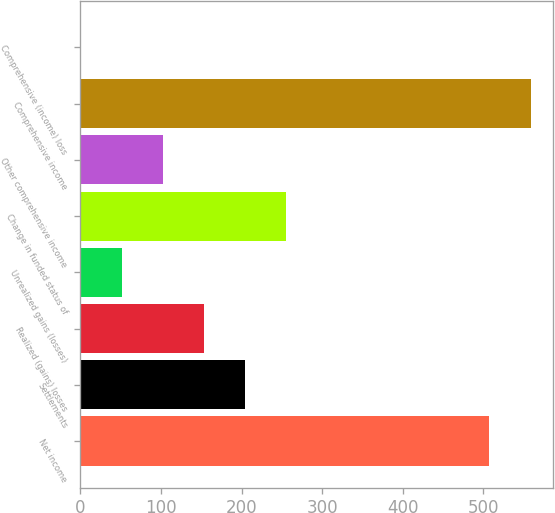Convert chart. <chart><loc_0><loc_0><loc_500><loc_500><bar_chart><fcel>Net income<fcel>Settlements<fcel>Realized (gains) losses<fcel>Unrealized gains (losses)<fcel>Change in funded status of<fcel>Other comprehensive income<fcel>Comprehensive income<fcel>Comprehensive (income) loss<nl><fcel>507.5<fcel>204.76<fcel>153.82<fcel>51.94<fcel>255.7<fcel>102.88<fcel>558.44<fcel>1<nl></chart> 